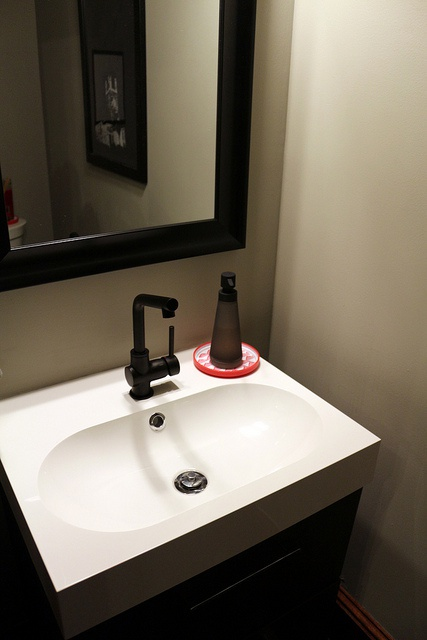Describe the objects in this image and their specific colors. I can see sink in black, white, lightgray, and tan tones and bottle in black, maroon, and white tones in this image. 